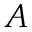Convert formula to latex. <formula><loc_0><loc_0><loc_500><loc_500>A</formula> 